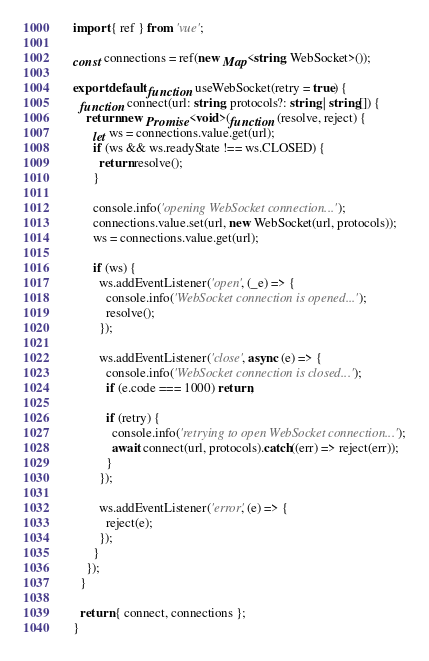Convert code to text. <code><loc_0><loc_0><loc_500><loc_500><_TypeScript_>import { ref } from 'vue';

const connections = ref(new Map<string, WebSocket>());

export default function useWebSocket(retry = true) {
  function connect(url: string, protocols?: string | string[]) {
    return new Promise<void>(function (resolve, reject) {
      let ws = connections.value.get(url);
      if (ws && ws.readyState !== ws.CLOSED) {
        return resolve();
      }

      console.info('opening WebSocket connection...');
      connections.value.set(url, new WebSocket(url, protocols));
      ws = connections.value.get(url);

      if (ws) {
        ws.addEventListener('open', (_e) => {
          console.info('WebSocket connection is opened...');
          resolve();
        });

        ws.addEventListener('close', async (e) => {
          console.info('WebSocket connection is closed...');
          if (e.code === 1000) return;

          if (retry) {
            console.info('retrying to open WebSocket connection...');
            await connect(url, protocols).catch((err) => reject(err));
          }
        });

        ws.addEventListener('error', (e) => {
          reject(e);
        });
      }
    });
  }

  return { connect, connections };
}
</code> 